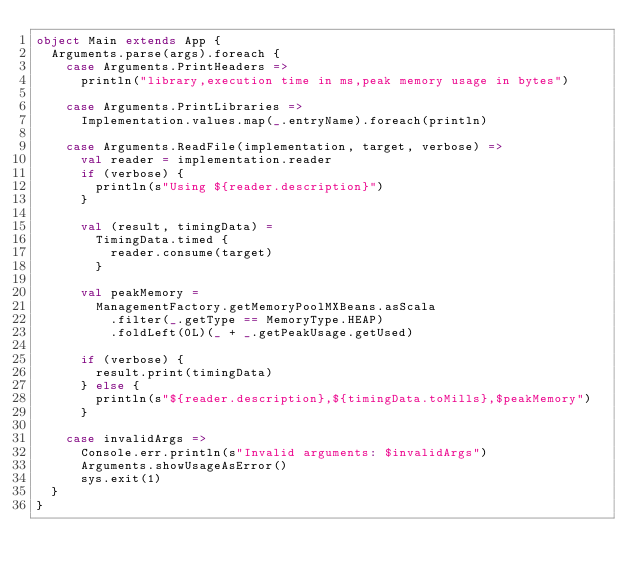<code> <loc_0><loc_0><loc_500><loc_500><_Scala_>object Main extends App {
  Arguments.parse(args).foreach {
    case Arguments.PrintHeaders =>
      println("library,execution time in ms,peak memory usage in bytes")

    case Arguments.PrintLibraries =>
      Implementation.values.map(_.entryName).foreach(println)

    case Arguments.ReadFile(implementation, target, verbose) =>
      val reader = implementation.reader
      if (verbose) {
        println(s"Using ${reader.description}")
      }

      val (result, timingData) =
        TimingData.timed {
          reader.consume(target)
        }

      val peakMemory =
        ManagementFactory.getMemoryPoolMXBeans.asScala
          .filter(_.getType == MemoryType.HEAP)
          .foldLeft(0L)(_ + _.getPeakUsage.getUsed)

      if (verbose) {
        result.print(timingData)
      } else {
        println(s"${reader.description},${timingData.toMills},$peakMemory")
      }

    case invalidArgs =>
      Console.err.println(s"Invalid arguments: $invalidArgs")
      Arguments.showUsageAsError()
      sys.exit(1)
  }
}
</code> 